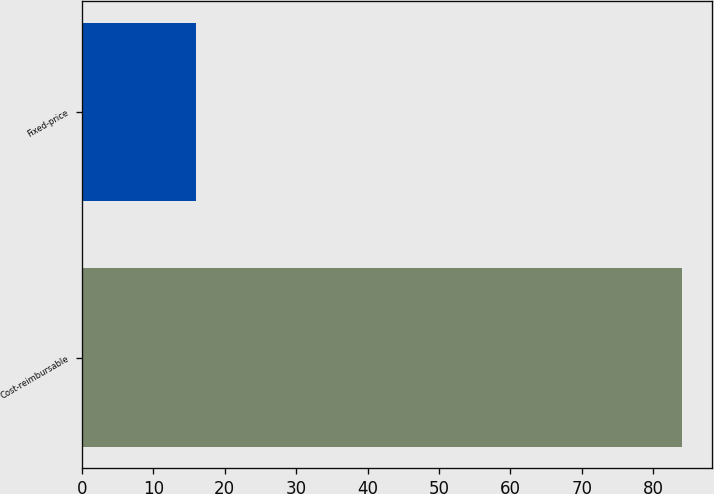<chart> <loc_0><loc_0><loc_500><loc_500><bar_chart><fcel>Cost-reimbursable<fcel>Fixed-price<nl><fcel>84<fcel>16<nl></chart> 